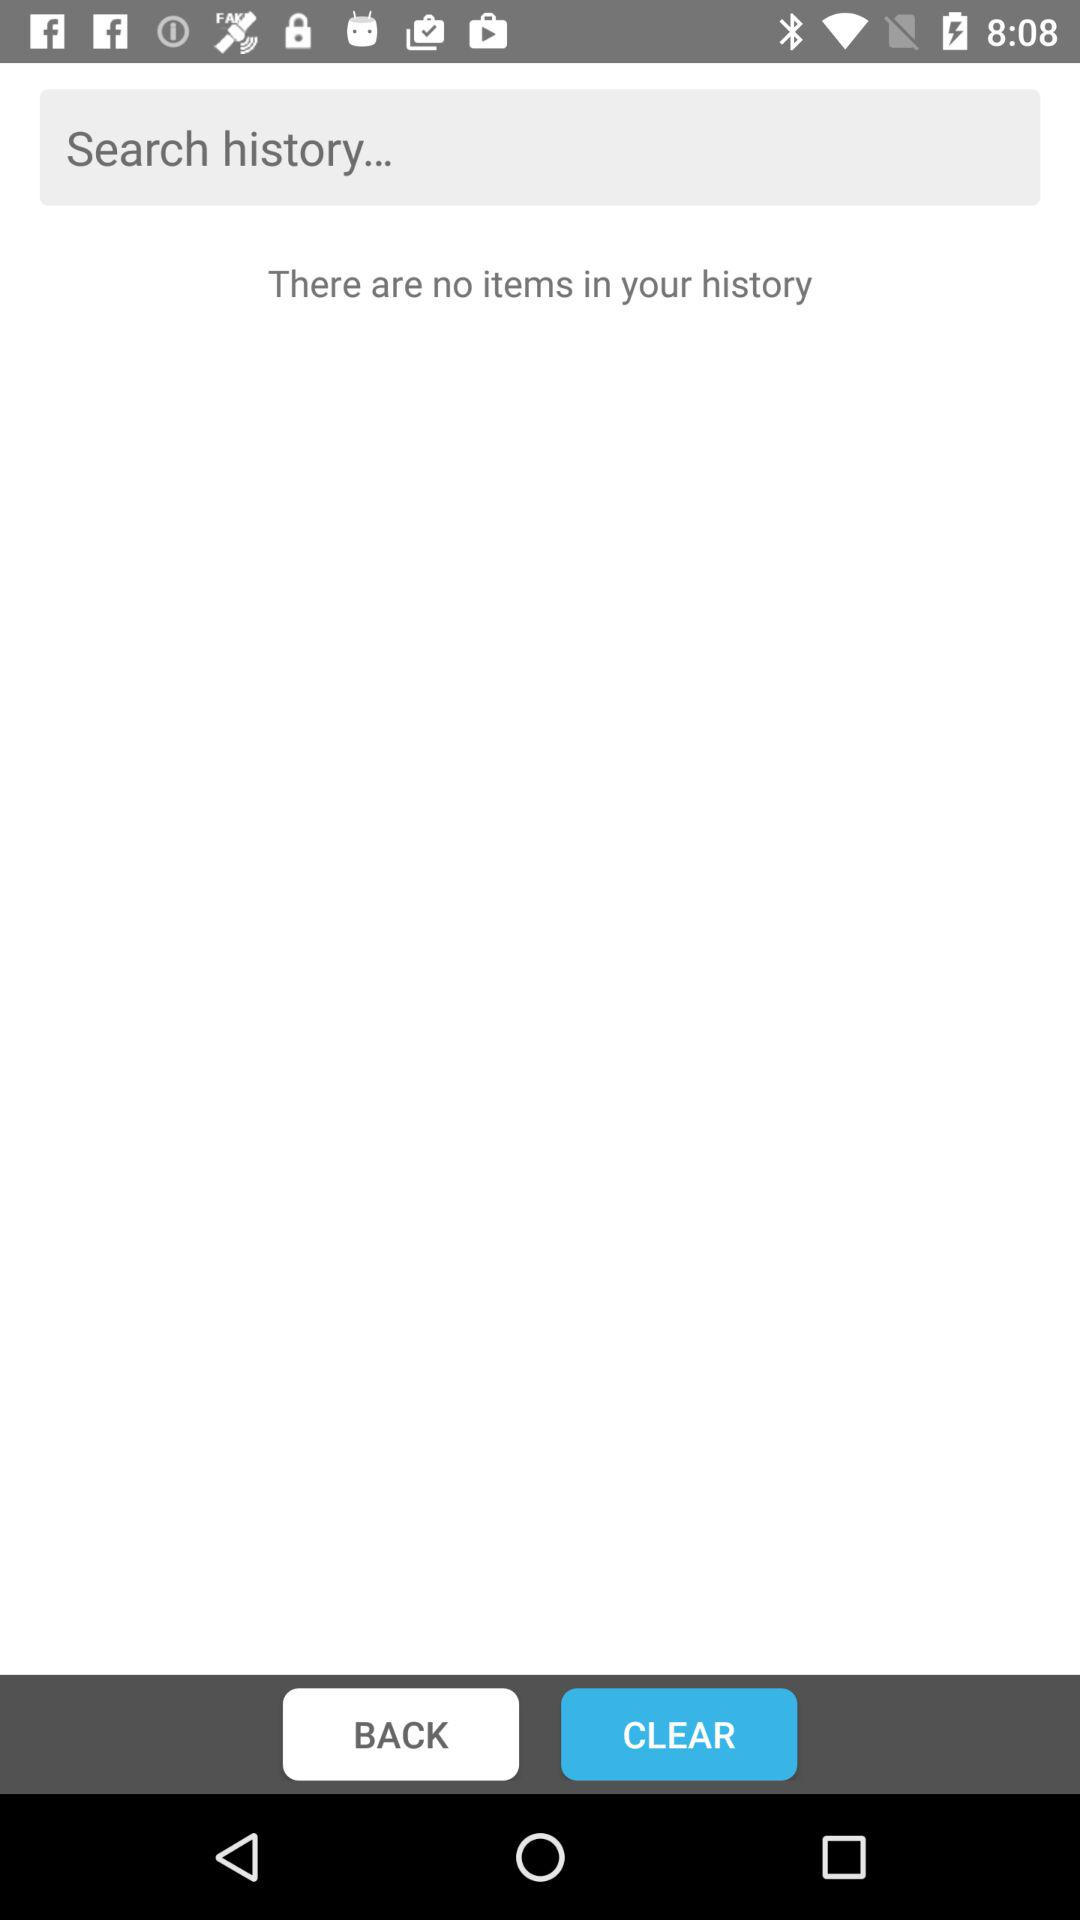How many items are there in the history? There are no items. 